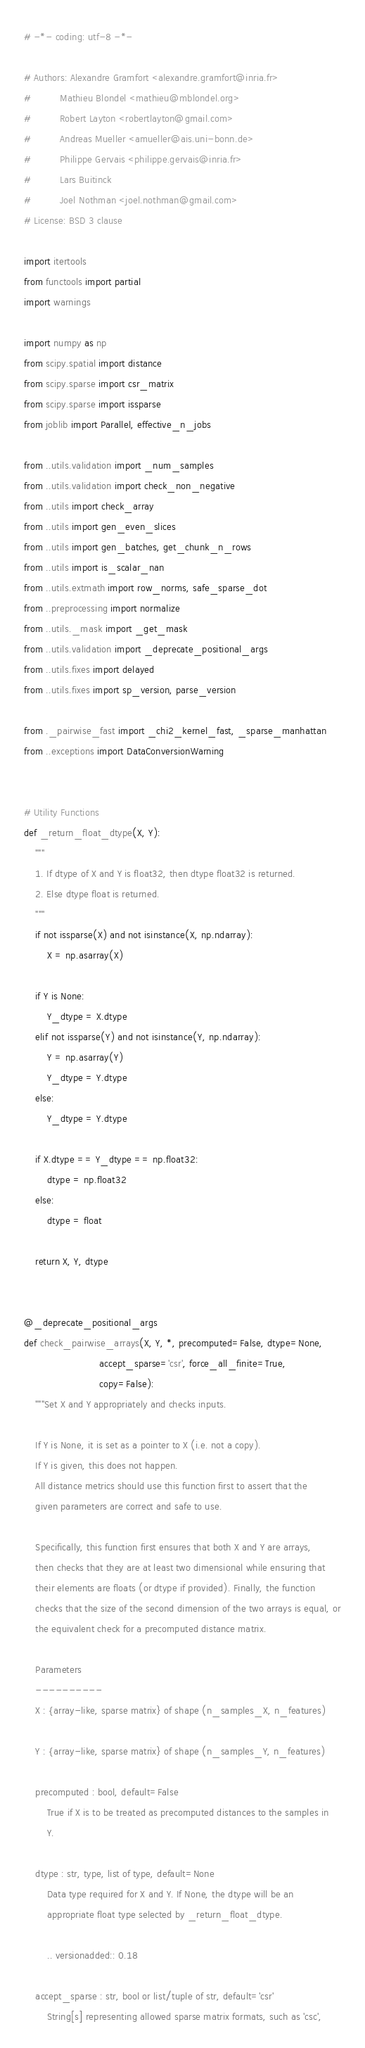Convert code to text. <code><loc_0><loc_0><loc_500><loc_500><_Python_># -*- coding: utf-8 -*-

# Authors: Alexandre Gramfort <alexandre.gramfort@inria.fr>
#          Mathieu Blondel <mathieu@mblondel.org>
#          Robert Layton <robertlayton@gmail.com>
#          Andreas Mueller <amueller@ais.uni-bonn.de>
#          Philippe Gervais <philippe.gervais@inria.fr>
#          Lars Buitinck
#          Joel Nothman <joel.nothman@gmail.com>
# License: BSD 3 clause

import itertools
from functools import partial
import warnings

import numpy as np
from scipy.spatial import distance
from scipy.sparse import csr_matrix
from scipy.sparse import issparse
from joblib import Parallel, effective_n_jobs

from ..utils.validation import _num_samples
from ..utils.validation import check_non_negative
from ..utils import check_array
from ..utils import gen_even_slices
from ..utils import gen_batches, get_chunk_n_rows
from ..utils import is_scalar_nan
from ..utils.extmath import row_norms, safe_sparse_dot
from ..preprocessing import normalize
from ..utils._mask import _get_mask
from ..utils.validation import _deprecate_positional_args
from ..utils.fixes import delayed
from ..utils.fixes import sp_version, parse_version

from ._pairwise_fast import _chi2_kernel_fast, _sparse_manhattan
from ..exceptions import DataConversionWarning


# Utility Functions
def _return_float_dtype(X, Y):
    """
    1. If dtype of X and Y is float32, then dtype float32 is returned.
    2. Else dtype float is returned.
    """
    if not issparse(X) and not isinstance(X, np.ndarray):
        X = np.asarray(X)

    if Y is None:
        Y_dtype = X.dtype
    elif not issparse(Y) and not isinstance(Y, np.ndarray):
        Y = np.asarray(Y)
        Y_dtype = Y.dtype
    else:
        Y_dtype = Y.dtype

    if X.dtype == Y_dtype == np.float32:
        dtype = np.float32
    else:
        dtype = float

    return X, Y, dtype


@_deprecate_positional_args
def check_pairwise_arrays(X, Y, *, precomputed=False, dtype=None,
                          accept_sparse='csr', force_all_finite=True,
                          copy=False):
    """Set X and Y appropriately and checks inputs.

    If Y is None, it is set as a pointer to X (i.e. not a copy).
    If Y is given, this does not happen.
    All distance metrics should use this function first to assert that the
    given parameters are correct and safe to use.

    Specifically, this function first ensures that both X and Y are arrays,
    then checks that they are at least two dimensional while ensuring that
    their elements are floats (or dtype if provided). Finally, the function
    checks that the size of the second dimension of the two arrays is equal, or
    the equivalent check for a precomputed distance matrix.

    Parameters
    ----------
    X : {array-like, sparse matrix} of shape (n_samples_X, n_features)

    Y : {array-like, sparse matrix} of shape (n_samples_Y, n_features)

    precomputed : bool, default=False
        True if X is to be treated as precomputed distances to the samples in
        Y.

    dtype : str, type, list of type, default=None
        Data type required for X and Y. If None, the dtype will be an
        appropriate float type selected by _return_float_dtype.

        .. versionadded:: 0.18

    accept_sparse : str, bool or list/tuple of str, default='csr'
        String[s] representing allowed sparse matrix formats, such as 'csc',</code> 